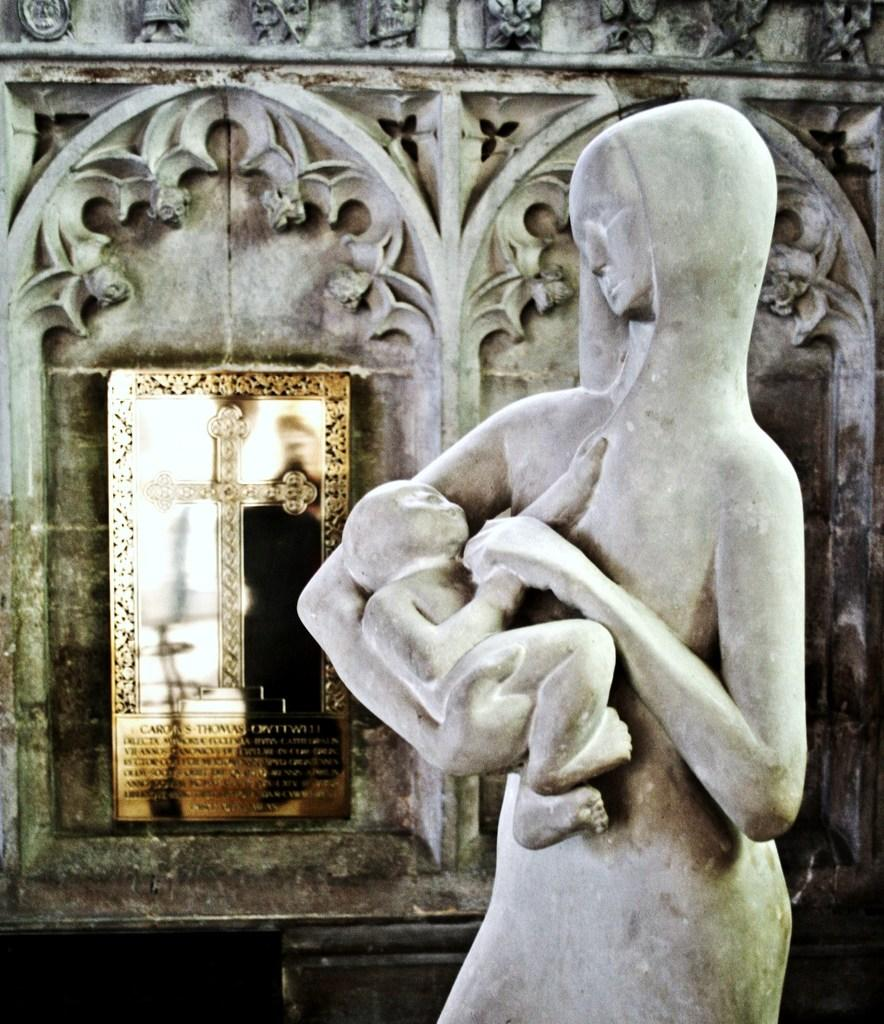What is the main subject of the image? The main subject of the image is a sculpture of two persons. What else can be seen in the image besides the sculpture? There is a board and art on a wall in the image. Can you describe the lighting in the image? The image may have been taken during the night, which suggests that the lighting is dim or artificial. What type of birthday celebration is depicted in the image? There is no birthday celebration depicted in the image; it features a sculpture of two persons, a board, and art on a wall. Can you point out the self in the image? There is no self present in the image, as it is a photograph of a sculpture, a board, and art on a wall. 